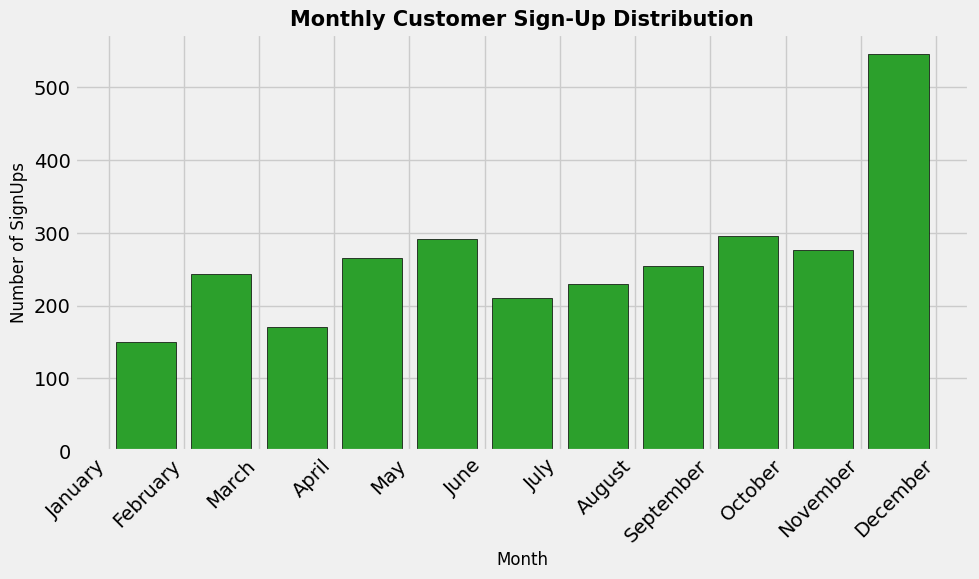Which month had the highest number of customer sign-ups? To find the month with the highest number of customer sign-ups, identify the tallest bar in the histogram. The tallest bar represents the month with the maximum number of sign-ups.
Answer: September Which two months had sign-ups within the 90-95 range most frequently? Look at the histogram and identify bars that fall within the range of 90-95 sign-ups. Checking the height and frequency of the bars will point to the months.
Answer: October and November What is the difference in the number of sign-ups between the month with the highest and the lowest sign-ups? The tallest bar represents the highest sign-ups (September: 295) and the shortest bar represents the lowest sign-ups (January: 150). Subtract the lowest from the highest.
Answer: 145 Which month had the lowest increase in customer sign-ups from the previous month? Find the difference in heights between consecutive bars to determine which subsequent month shows the smallest increase compared to its previous month.
Answer: March What is the total number of sign-ups in the first quarter (January to March)? Add the values of sign-ups for January, February, and March. Sum January: 150, February: 243, and March: 171 to get the result.
Answer: 564 Which months had approximately the same number of sign-ups? Look for bars of similar heights in the histogram. Check values where the bars' heights are nearly equal.
Answer: December and October Is there a clear trend in the number of sign-ups over the year? Analyze the visual pattern or slope of the bars. If the bars increase or decrease consistently, there is a trend.
Answer: Slight upward trend How many months had sign-ups greater than 85? Count the bars that surpass the 85-sign-up mark to find the number of qualifying months.
Answer: 9 